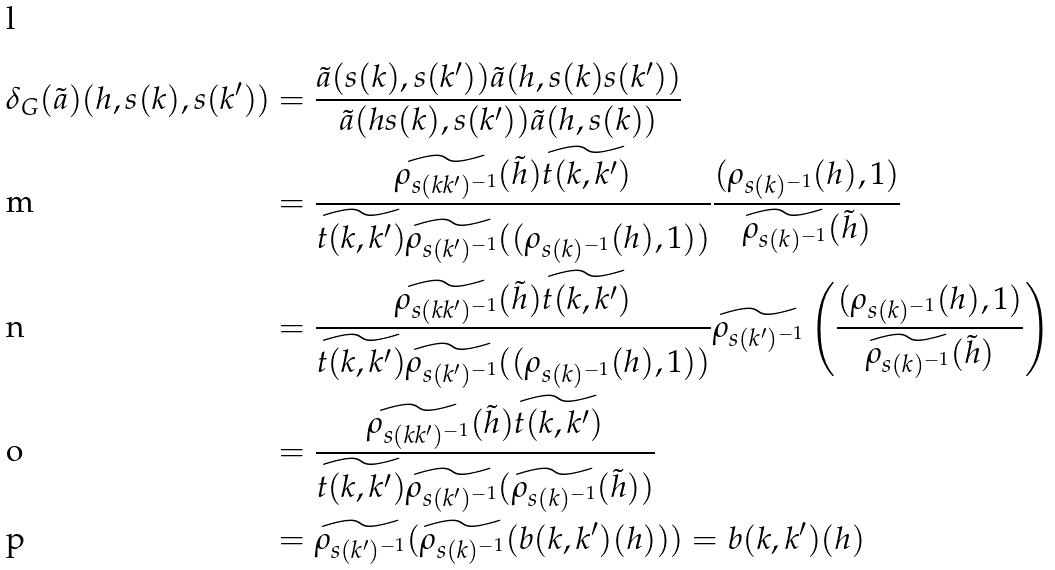<formula> <loc_0><loc_0><loc_500><loc_500>\delta _ { G } ( \tilde { a } ) ( h , s ( k ) , s ( k ^ { \prime } ) ) & = \frac { \tilde { a } ( s ( k ) , s ( k ^ { \prime } ) ) \tilde { a } ( h , s ( k ) s ( k ^ { \prime } ) ) } { \tilde { a } ( h s ( k ) , s ( k ^ { \prime } ) ) \tilde { a } ( h , s ( k ) ) } \\ & = \frac { \widetilde { \rho _ { s ( k k ^ { \prime } ) ^ { - 1 } } } ( \tilde { h } ) \widetilde { t ( k , k ^ { \prime } ) } } { \widetilde { t ( k , k ^ { \prime } ) } \widetilde { \rho _ { s ( k ^ { \prime } ) ^ { - 1 } } } ( ( \rho _ { s ( k ) ^ { - 1 } } ( h ) , 1 ) ) } \frac { ( \rho _ { s ( k ) ^ { - 1 } } ( h ) , 1 ) } { \widetilde { \rho _ { s ( k ) ^ { - 1 } } } ( \tilde { h } ) } \\ & = \frac { \widetilde { \rho _ { s ( k k ^ { \prime } ) ^ { - 1 } } } ( \tilde { h } ) \widetilde { t ( k , k ^ { \prime } ) } } { \widetilde { t ( k , k ^ { \prime } ) } \widetilde { \rho _ { s ( k ^ { \prime } ) ^ { - 1 } } } ( ( \rho _ { s ( k ) ^ { - 1 } } ( h ) , 1 ) ) } \widetilde { \rho _ { s ( k ^ { \prime } ) ^ { - 1 } } } \left ( \frac { ( \rho _ { s ( k ) ^ { - 1 } } ( h ) , 1 ) } { \widetilde { \rho _ { s ( k ) ^ { - 1 } } } ( \tilde { h } ) } \right ) \\ & = \frac { \widetilde { \rho _ { s ( k k ^ { \prime } ) ^ { - 1 } } } ( \tilde { h } ) \widetilde { t ( k , k ^ { \prime } ) } } { \widetilde { t ( k , k ^ { \prime } ) } \widetilde { \rho _ { s ( k ^ { \prime } ) ^ { - 1 } } } ( \widetilde { \rho _ { s ( k ) ^ { - 1 } } } ( \tilde { h } ) ) } \\ & = \widetilde { \rho _ { s ( k ^ { \prime } ) ^ { - 1 } } } ( \widetilde { \rho _ { s ( k ) ^ { - 1 } } } ( b ( k , k ^ { \prime } ) ( h ) ) ) = b ( k , k ^ { \prime } ) ( h )</formula> 